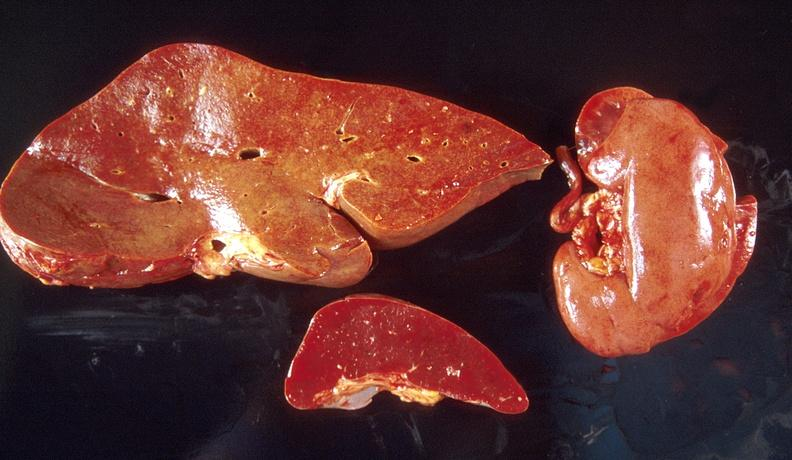what is present?
Answer the question using a single word or phrase. Hepatobiliary 